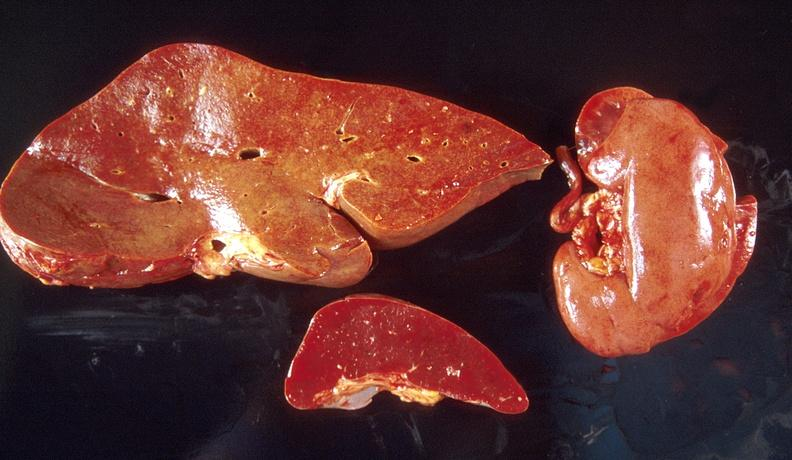what is present?
Answer the question using a single word or phrase. Hepatobiliary 